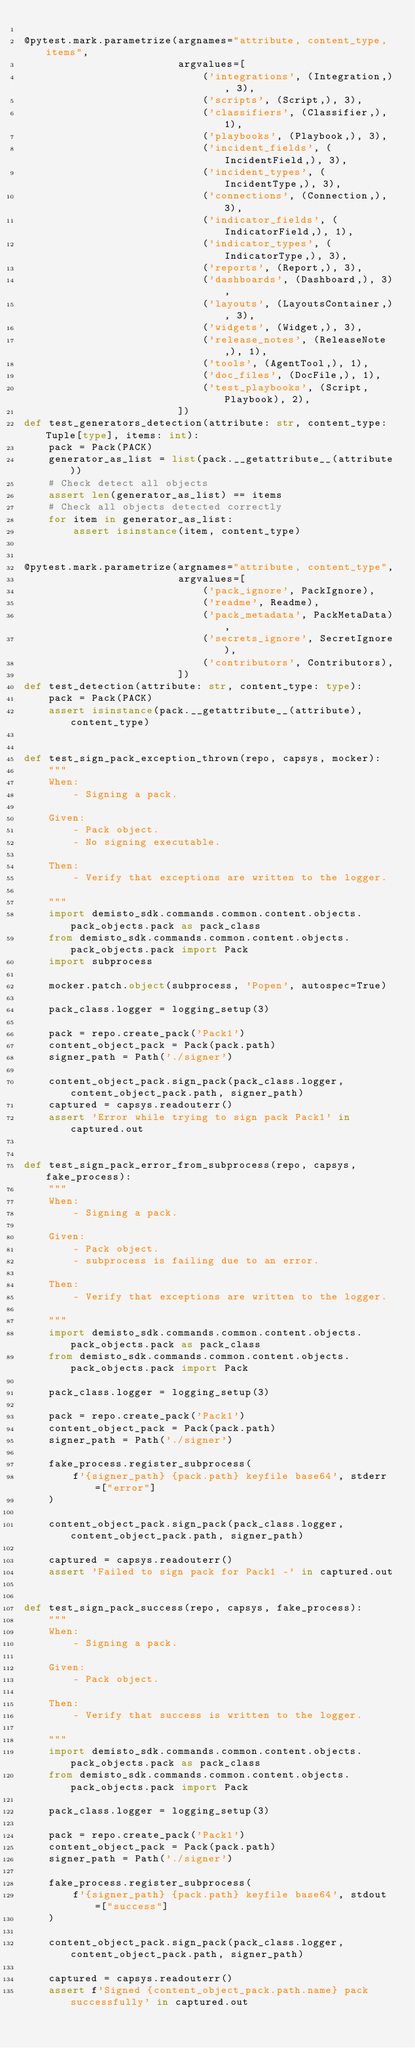Convert code to text. <code><loc_0><loc_0><loc_500><loc_500><_Python_>
@pytest.mark.parametrize(argnames="attribute, content_type, items",
                         argvalues=[
                             ('integrations', (Integration,), 3),
                             ('scripts', (Script,), 3),
                             ('classifiers', (Classifier,), 1),
                             ('playbooks', (Playbook,), 3),
                             ('incident_fields', (IncidentField,), 3),
                             ('incident_types', (IncidentType,), 3),
                             ('connections', (Connection,), 3),
                             ('indicator_fields', (IndicatorField,), 1),
                             ('indicator_types', (IndicatorType,), 3),
                             ('reports', (Report,), 3),
                             ('dashboards', (Dashboard,), 3),
                             ('layouts', (LayoutsContainer,), 3),
                             ('widgets', (Widget,), 3),
                             ('release_notes', (ReleaseNote,), 1),
                             ('tools', (AgentTool,), 1),
                             ('doc_files', (DocFile,), 1),
                             ('test_playbooks', (Script, Playbook), 2),
                         ])
def test_generators_detection(attribute: str, content_type: Tuple[type], items: int):
    pack = Pack(PACK)
    generator_as_list = list(pack.__getattribute__(attribute))
    # Check detect all objects
    assert len(generator_as_list) == items
    # Check all objects detected correctly
    for item in generator_as_list:
        assert isinstance(item, content_type)


@pytest.mark.parametrize(argnames="attribute, content_type",
                         argvalues=[
                             ('pack_ignore', PackIgnore),
                             ('readme', Readme),
                             ('pack_metadata', PackMetaData),
                             ('secrets_ignore', SecretIgnore),
                             ('contributors', Contributors),
                         ])
def test_detection(attribute: str, content_type: type):
    pack = Pack(PACK)
    assert isinstance(pack.__getattribute__(attribute), content_type)


def test_sign_pack_exception_thrown(repo, capsys, mocker):
    """
    When:
        - Signing a pack.

    Given:
        - Pack object.
        - No signing executable.

    Then:
        - Verify that exceptions are written to the logger.

    """
    import demisto_sdk.commands.common.content.objects.pack_objects.pack as pack_class
    from demisto_sdk.commands.common.content.objects.pack_objects.pack import Pack
    import subprocess

    mocker.patch.object(subprocess, 'Popen', autospec=True)

    pack_class.logger = logging_setup(3)

    pack = repo.create_pack('Pack1')
    content_object_pack = Pack(pack.path)
    signer_path = Path('./signer')

    content_object_pack.sign_pack(pack_class.logger, content_object_pack.path, signer_path)
    captured = capsys.readouterr()
    assert 'Error while trying to sign pack Pack1' in captured.out


def test_sign_pack_error_from_subprocess(repo, capsys, fake_process):
    """
    When:
        - Signing a pack.

    Given:
        - Pack object.
        - subprocess is failing due to an error.

    Then:
        - Verify that exceptions are written to the logger.

    """
    import demisto_sdk.commands.common.content.objects.pack_objects.pack as pack_class
    from demisto_sdk.commands.common.content.objects.pack_objects.pack import Pack

    pack_class.logger = logging_setup(3)

    pack = repo.create_pack('Pack1')
    content_object_pack = Pack(pack.path)
    signer_path = Path('./signer')

    fake_process.register_subprocess(
        f'{signer_path} {pack.path} keyfile base64', stderr=["error"]
    )

    content_object_pack.sign_pack(pack_class.logger, content_object_pack.path, signer_path)

    captured = capsys.readouterr()
    assert 'Failed to sign pack for Pack1 -' in captured.out


def test_sign_pack_success(repo, capsys, fake_process):
    """
    When:
        - Signing a pack.

    Given:
        - Pack object.

    Then:
        - Verify that success is written to the logger.

    """
    import demisto_sdk.commands.common.content.objects.pack_objects.pack as pack_class
    from demisto_sdk.commands.common.content.objects.pack_objects.pack import Pack

    pack_class.logger = logging_setup(3)

    pack = repo.create_pack('Pack1')
    content_object_pack = Pack(pack.path)
    signer_path = Path('./signer')

    fake_process.register_subprocess(
        f'{signer_path} {pack.path} keyfile base64', stdout=["success"]
    )

    content_object_pack.sign_pack(pack_class.logger, content_object_pack.path, signer_path)

    captured = capsys.readouterr()
    assert f'Signed {content_object_pack.path.name} pack successfully' in captured.out
</code> 